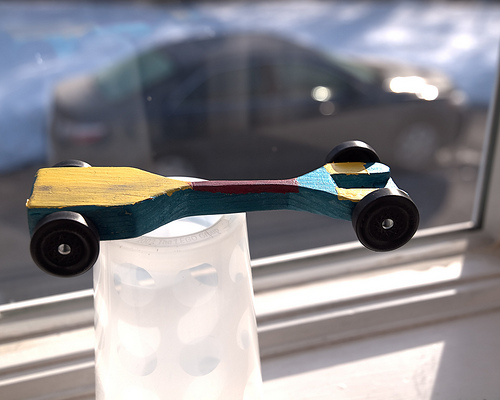<image>
Is the car behind the glass? No. The car is not behind the glass. From this viewpoint, the car appears to be positioned elsewhere in the scene. 